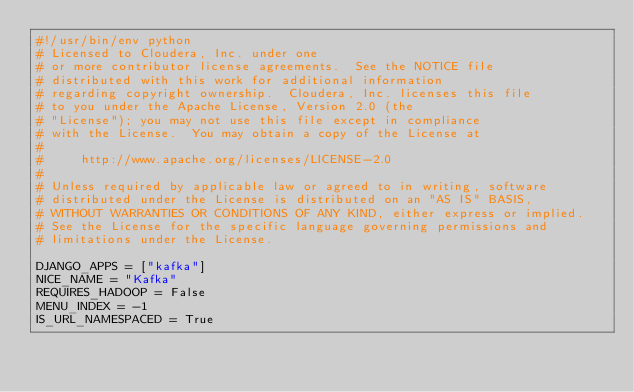Convert code to text. <code><loc_0><loc_0><loc_500><loc_500><_Python_>#!/usr/bin/env python
# Licensed to Cloudera, Inc. under one
# or more contributor license agreements.  See the NOTICE file
# distributed with this work for additional information
# regarding copyright ownership.  Cloudera, Inc. licenses this file
# to you under the Apache License, Version 2.0 (the
# "License"); you may not use this file except in compliance
# with the License.  You may obtain a copy of the License at
#
#     http://www.apache.org/licenses/LICENSE-2.0
#
# Unless required by applicable law or agreed to in writing, software
# distributed under the License is distributed on an "AS IS" BASIS,
# WITHOUT WARRANTIES OR CONDITIONS OF ANY KIND, either express or implied.
# See the License for the specific language governing permissions and
# limitations under the License.

DJANGO_APPS = ["kafka"]
NICE_NAME = "Kafka"
REQUIRES_HADOOP = False
MENU_INDEX = -1
IS_URL_NAMESPACED = True
</code> 